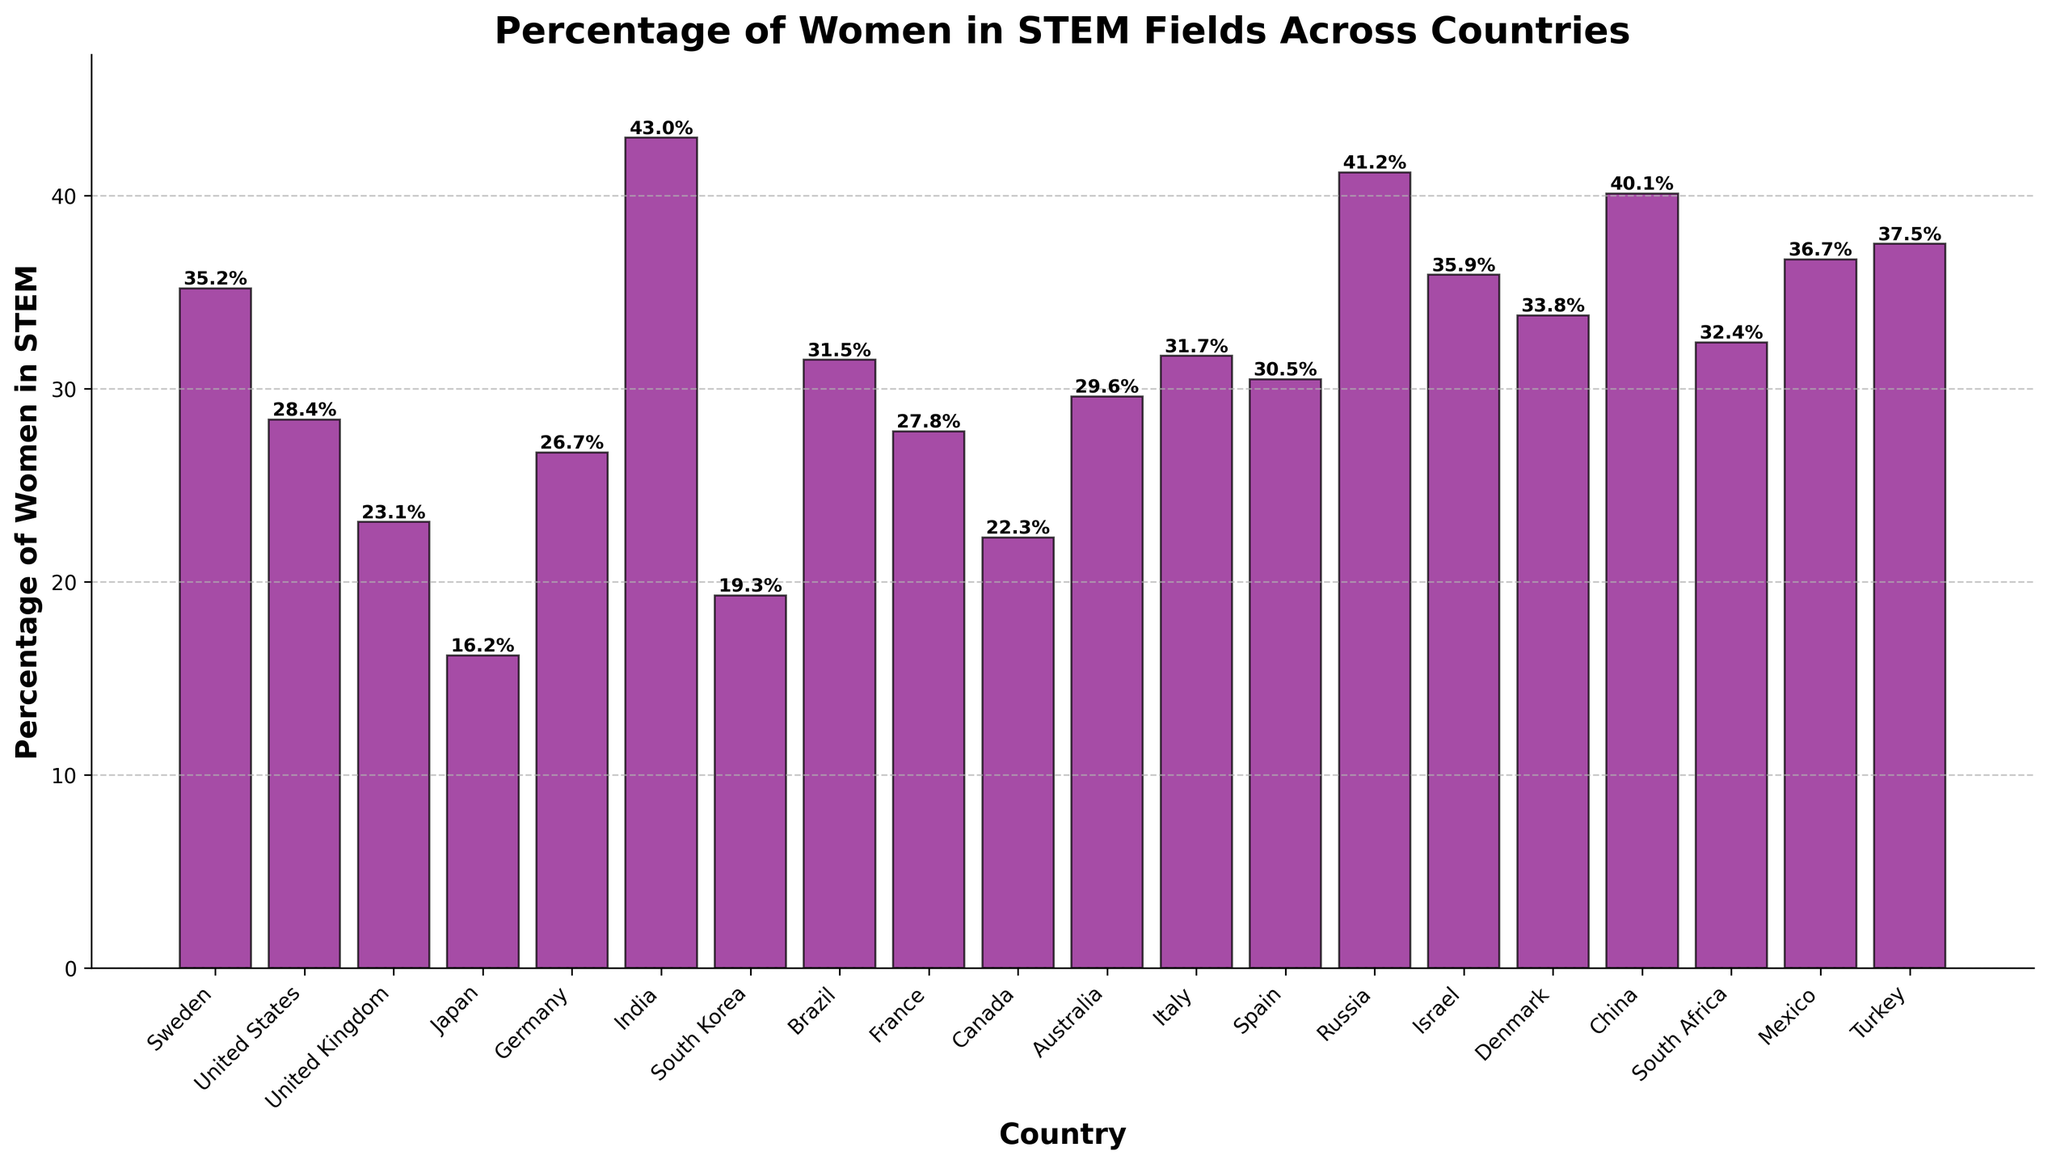Which country has the highest percentage of women in STEM fields? By visually examining the heights of the bars, the bar for India is the tallest, indicating it has the highest percentage.
Answer: India Which country has a lower percentage of women in STEM fields, Japan or South Korea? Comparing the heights of the bars for Japan and South Korea, the bar for Japan is shorter. Thus, Japan has a lower percentage of women in STEM fields.
Answer: Japan What is the percentage difference between the United States and Canada in terms of women in STEM fields? The bar for the United States reads 28.4% and Canada reads 22.3%. The difference is 28.4 - 22.3 = 6.1%.
Answer: 6.1% Which country has a higher percentage of women in STEM fields, Turkey or China? By examining the bars, the bar for Turkey is slightly taller than the one for China, which indicates Turkey has a higher percentage.
Answer: Turkey What is the total percentage of women in STEM fields for the top three countries combined? The top three countries by percentage are India (43.0%), Russia (41.2%), and China (40.1%). The total is 43.0 + 41.2 + 40.1 = 124.3%.
Answer: 124.3% What is the average percentage of women in STEM fields across all countries? To find the average, sum all percentages and divide by the number of countries. The percentages sum to 517.2% and there are 20 countries, thus the average is 517.2 / 20 = 25.9%.
Answer: 25.9% Which country has a higher percentage of women in STEM fields, Italy or Denmark? Comparing the heights of the bars for Italy and Denmark, Italy's bar is slightly taller, indicating a higher percentage.
Answer: Italy How many countries have a percentage of women in STEM fields above 30%? By scanning the heights of the bars, we see that Sweden, Brazil, Italy, Spain, Russia, China, Israel, Mexico, and Turkey have bars above the 30% line. There are 9 such countries in total.
Answer: 9 What is the median percentage of women in STEM fields among these countries? Ordering the percentages: 16.2, 19.3, 22.3, 23.1, 26.7, 27.8, 28.4, 29.6, 30.5, 31.5, 31.7, 32.4, 33.8, 35.2, 35.9, 36.7, 37.5, 40.1, 41.2, 43.0, the middle values are 29.6 and 30.5. The median is (29.6 + 30.5) / 2 = 30.05.
Answer: 30.05 What is the percentage difference between the country with the highest and the lowest percentage of women in STEM fields? The highest percentage is India (43.0%) and the lowest is Japan (16.2%). The difference is 43.0 - 16.2 = 26.8%.
Answer: 26.8% 